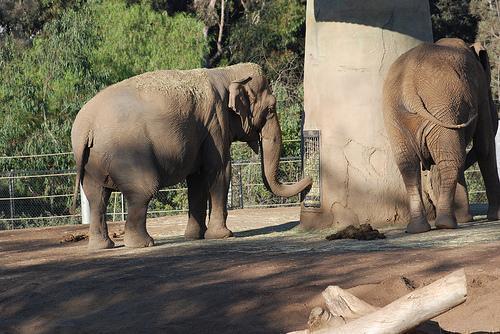How many elephants are there?
Give a very brief answer. 2. How many animals are here?
Give a very brief answer. 2. How many of the animals' heads are visible?
Give a very brief answer. 1. How many feet are on the ground?
Give a very brief answer. 8. How many tails are visible?
Give a very brief answer. 2. 